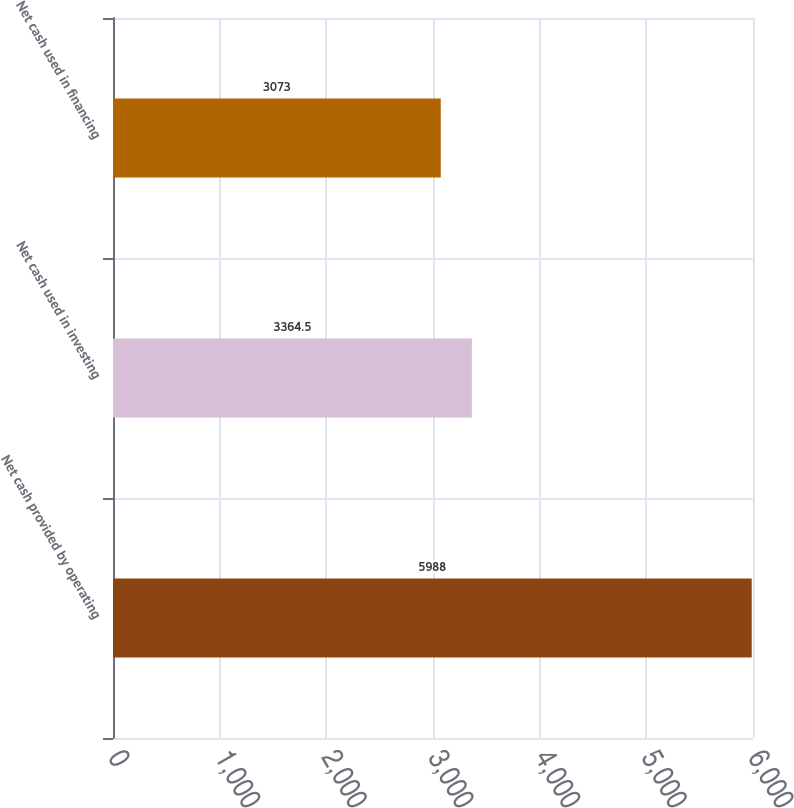Convert chart. <chart><loc_0><loc_0><loc_500><loc_500><bar_chart><fcel>Net cash provided by operating<fcel>Net cash used in investing<fcel>Net cash used in financing<nl><fcel>5988<fcel>3364.5<fcel>3073<nl></chart> 